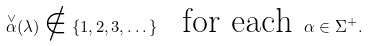<formula> <loc_0><loc_0><loc_500><loc_500>\overset { \vee } { \alpha } ( \lambda ) \notin \left \{ 1 , 2 , 3 , \dots \right \} \text { \ for each } \alpha \in \Sigma ^ { + } . \</formula> 